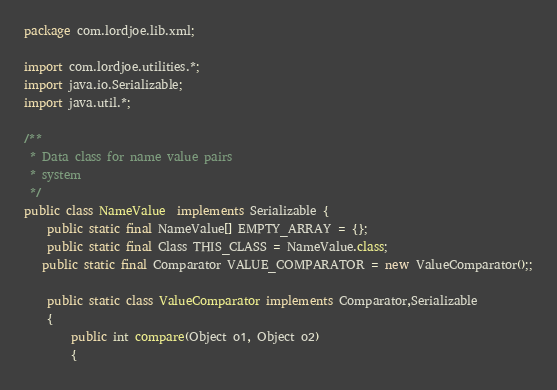Convert code to text. <code><loc_0><loc_0><loc_500><loc_500><_Java_>package com.lordjoe.lib.xml;

import com.lordjoe.utilities.*;
import java.io.Serializable;
import java.util.*;

/**
 * Data class for name value pairs
 * system
 */
public class NameValue  implements Serializable {
    public static final NameValue[] EMPTY_ARRAY = {};
    public static final Class THIS_CLASS = NameValue.class;
   public static final Comparator VALUE_COMPARATOR = new ValueComparator();;

    public static class ValueComparator implements Comparator,Serializable
    {
        public int compare(Object o1, Object o2)
        {</code> 